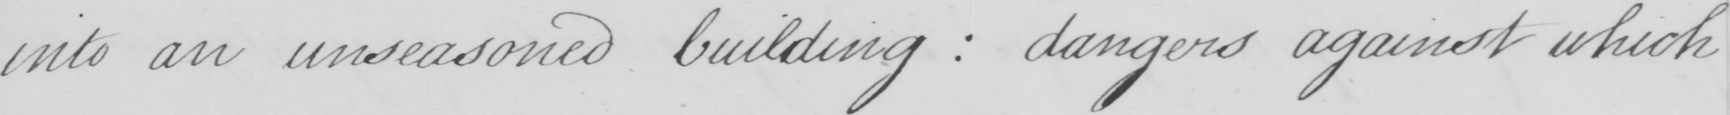What does this handwritten line say? into an unseasoned building :  dangers against which 